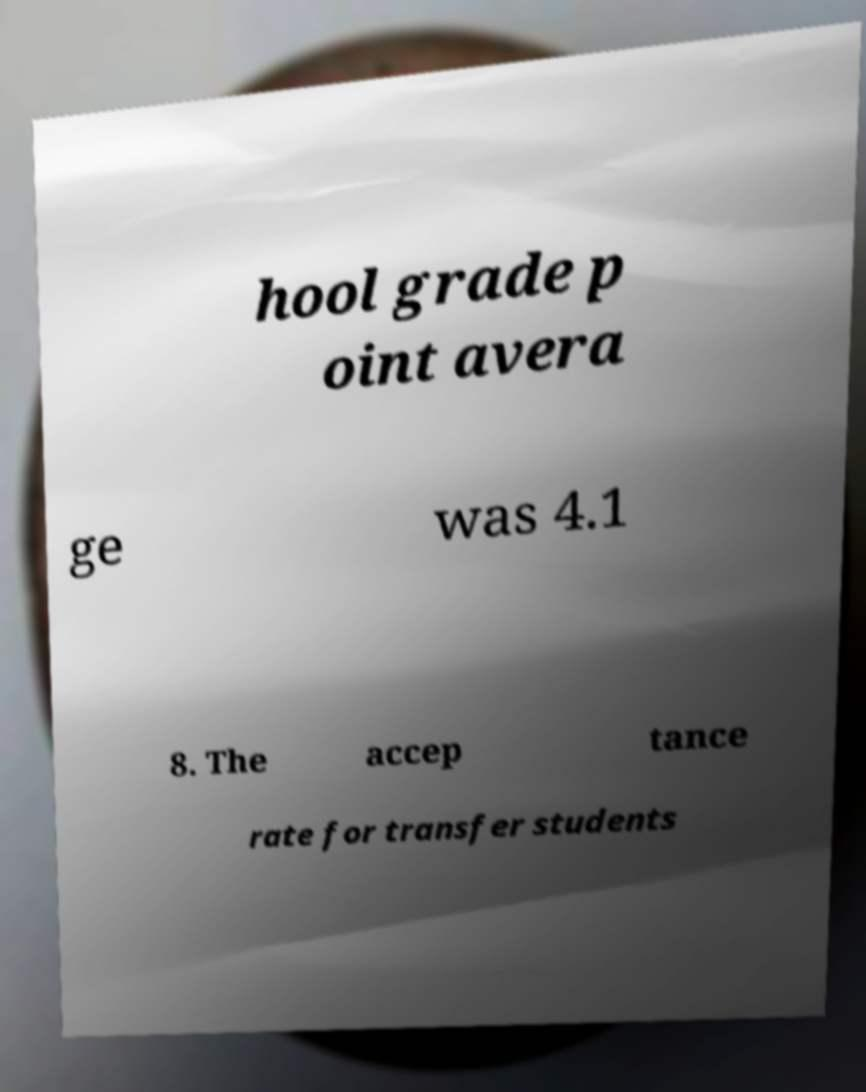There's text embedded in this image that I need extracted. Can you transcribe it verbatim? hool grade p oint avera ge was 4.1 8. The accep tance rate for transfer students 